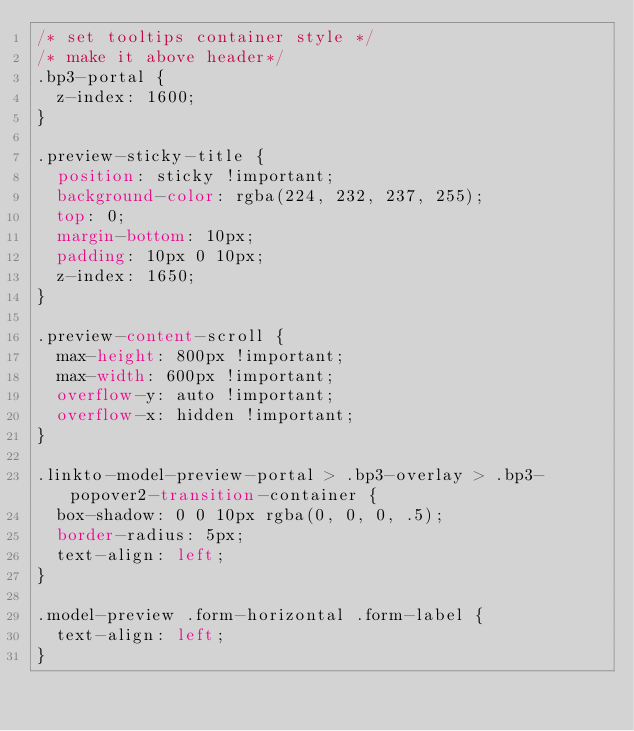<code> <loc_0><loc_0><loc_500><loc_500><_CSS_>/* set tooltips container style */
/* make it above header*/
.bp3-portal {
  z-index: 1600;
}

.preview-sticky-title {
  position: sticky !important;
  background-color: rgba(224, 232, 237, 255);
  top: 0;
  margin-bottom: 10px;
  padding: 10px 0 10px;
  z-index: 1650;
}

.preview-content-scroll {
  max-height: 800px !important;
  max-width: 600px !important;
  overflow-y: auto !important;
  overflow-x: hidden !important;
}

.linkto-model-preview-portal > .bp3-overlay > .bp3-popover2-transition-container {
  box-shadow: 0 0 10px rgba(0, 0, 0, .5);
  border-radius: 5px;
  text-align: left;
}

.model-preview .form-horizontal .form-label {
  text-align: left;
}
</code> 